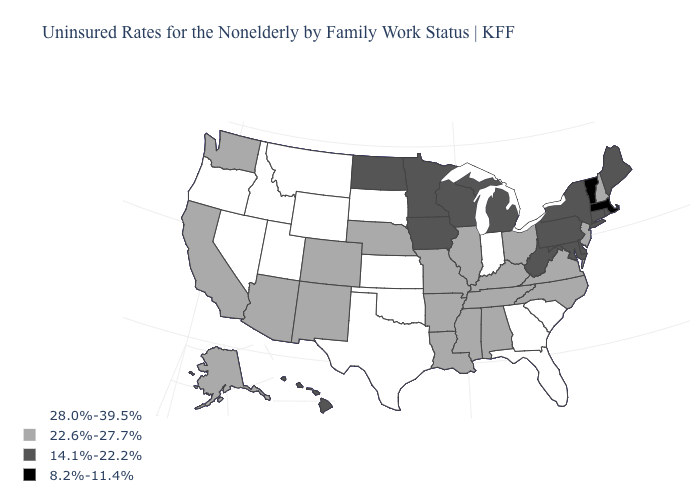Name the states that have a value in the range 8.2%-11.4%?
Write a very short answer. Massachusetts, Vermont. Name the states that have a value in the range 8.2%-11.4%?
Concise answer only. Massachusetts, Vermont. Does Illinois have the same value as South Carolina?
Concise answer only. No. Name the states that have a value in the range 14.1%-22.2%?
Write a very short answer. Connecticut, Delaware, Hawaii, Iowa, Maine, Maryland, Michigan, Minnesota, New York, North Dakota, Pennsylvania, Rhode Island, West Virginia, Wisconsin. Which states have the highest value in the USA?
Keep it brief. Florida, Georgia, Idaho, Indiana, Kansas, Montana, Nevada, Oklahoma, Oregon, South Carolina, South Dakota, Texas, Utah, Wyoming. Does Pennsylvania have the highest value in the Northeast?
Short answer required. No. Which states hav the highest value in the West?
Short answer required. Idaho, Montana, Nevada, Oregon, Utah, Wyoming. Among the states that border Idaho , does Washington have the highest value?
Write a very short answer. No. Which states have the lowest value in the MidWest?
Answer briefly. Iowa, Michigan, Minnesota, North Dakota, Wisconsin. What is the value of Washington?
Be succinct. 22.6%-27.7%. Among the states that border New Jersey , which have the highest value?
Concise answer only. Delaware, New York, Pennsylvania. Name the states that have a value in the range 14.1%-22.2%?
Concise answer only. Connecticut, Delaware, Hawaii, Iowa, Maine, Maryland, Michigan, Minnesota, New York, North Dakota, Pennsylvania, Rhode Island, West Virginia, Wisconsin. What is the value of Alabama?
Short answer required. 22.6%-27.7%. What is the value of North Dakota?
Give a very brief answer. 14.1%-22.2%. Does Vermont have the lowest value in the USA?
Write a very short answer. Yes. 